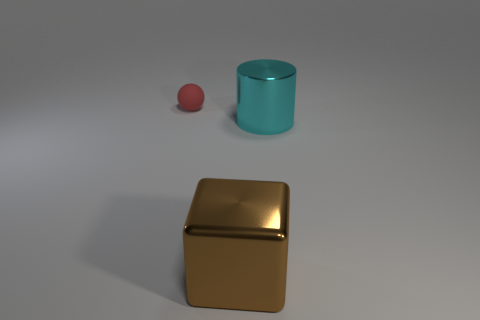Add 3 small balls. How many objects exist? 6 Subtract all balls. How many objects are left? 2 Add 1 tiny objects. How many tiny objects exist? 2 Subtract 0 red blocks. How many objects are left? 3 Subtract all red matte balls. Subtract all large cyan metallic objects. How many objects are left? 1 Add 3 big cyan metallic cylinders. How many big cyan metallic cylinders are left? 4 